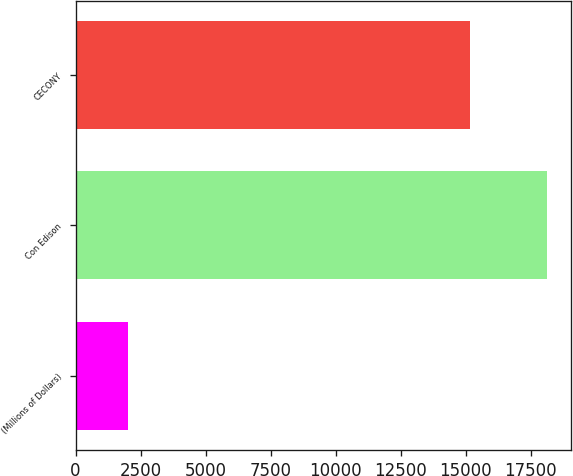<chart> <loc_0><loc_0><loc_500><loc_500><bar_chart><fcel>(Millions of Dollars)<fcel>Con Edison<fcel>CECONY<nl><fcel>2017<fcel>18147<fcel>15163<nl></chart> 